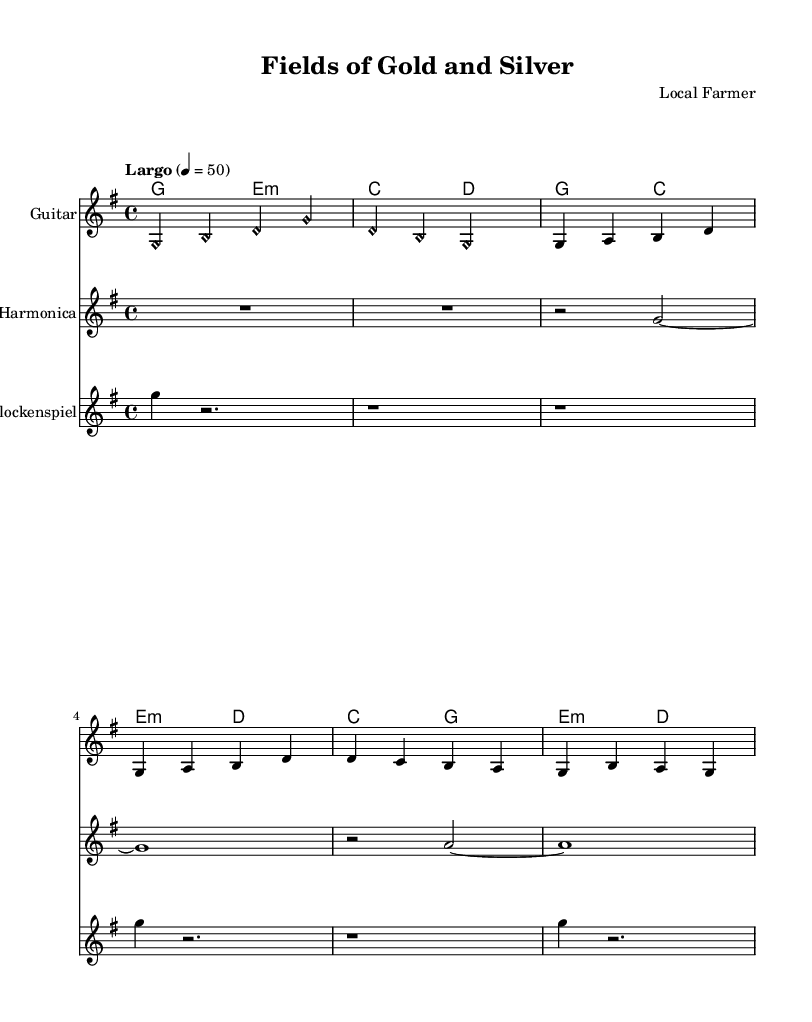What is the key signature of this music? The key signature is G major, which has one sharp (F#).
Answer: G major What is the time signature of this music? The time signature is 4/4, indicating four beats per measure.
Answer: 4/4 What is the tempo marking of this piece? The tempo marking is Largo, which indicates a slow pace.
Answer: Largo How many measures are in the intro section? The intro section consists of 2 measures as indicated by the notation.
Answer: 2 What type of harmony is used in the guitar section during the chorus? The guitar section employs chord harmony using seventh chords like G and E minor.
Answer: Seventh chords What instruments are featured in this arrangement? The arrangement features guitar, harmonica, and glockenspiel as indicated by the staff labels.
Answer: Guitar, harmonica, glockenspiel Explain the relationship between agriculture and responsible resource extraction in the context of the music type chosen. The music showcases minimalist acoustic arrangements that symbolize the connection between nature (agriculture) and the use of natural resources (responsible extraction). The harmony in the composition reflects the theme of balance between these two elements.
Answer: Harmony between nature and resources 